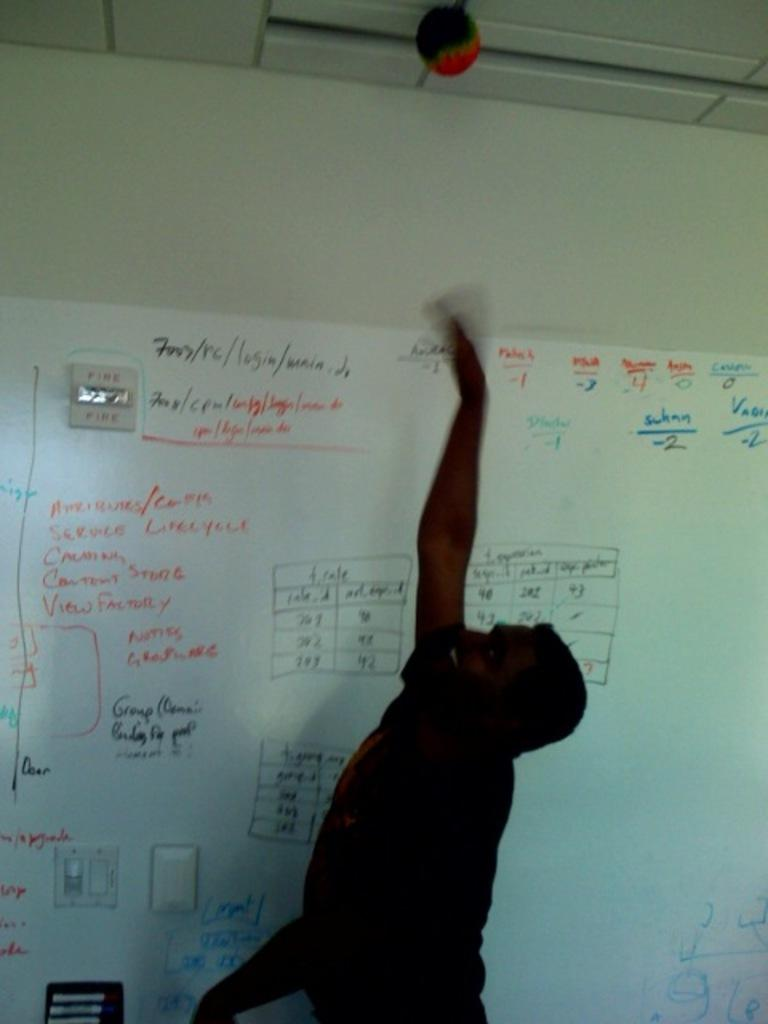Provide a one-sentence caption for the provided image. The boys vertical jump was -2 and according to the chart, below average. 